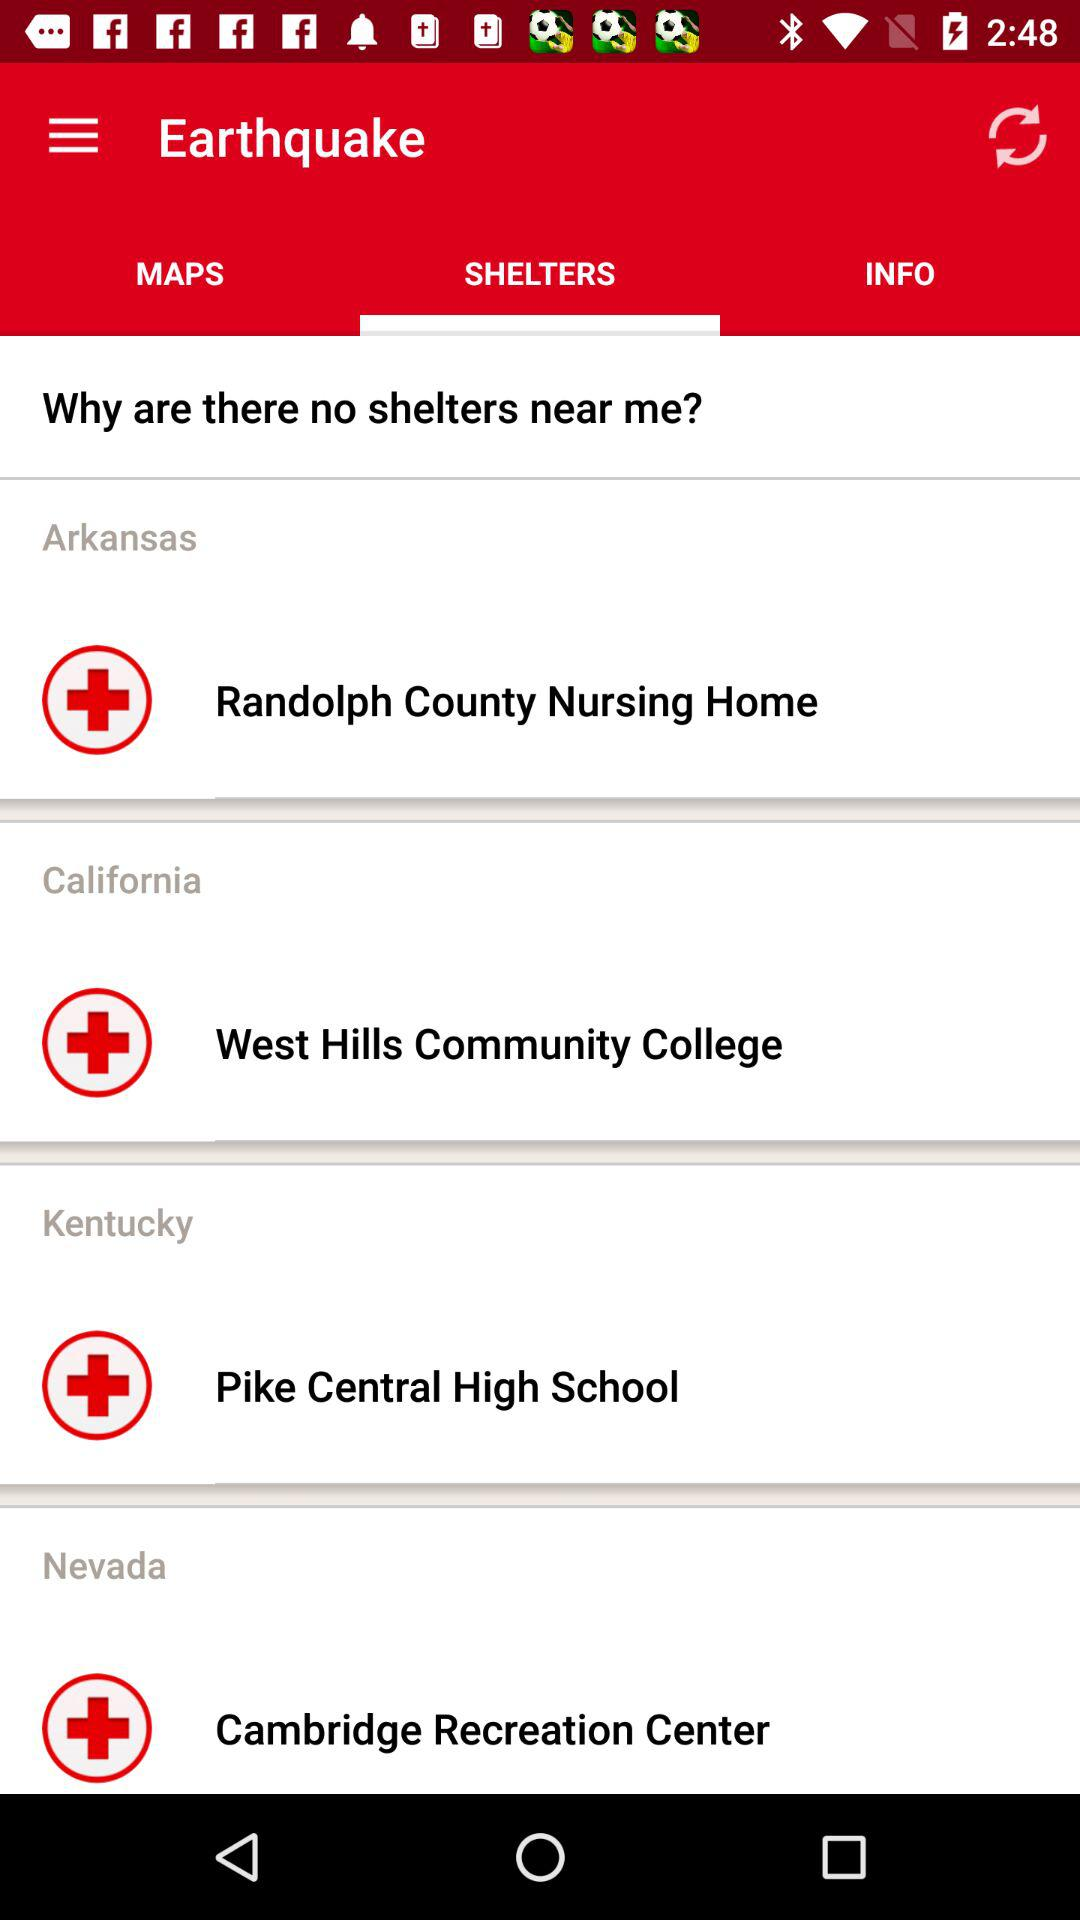In which country is "West Hills Community College" located? "West Hills Community College" is located in California. 